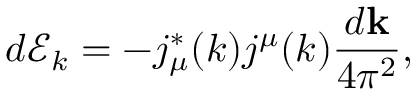<formula> <loc_0><loc_0><loc_500><loc_500>d \mathcal { E } _ { k } = - j _ { \mu } ^ { * } ( k ) j ^ { \mu } ( k ) \frac { d k } { 4 \pi ^ { 2 } } ,</formula> 